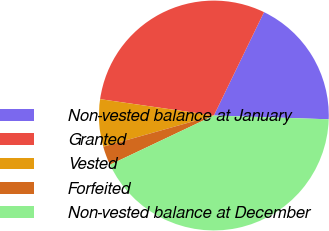Convert chart to OTSL. <chart><loc_0><loc_0><loc_500><loc_500><pie_chart><fcel>Non-vested balance at January<fcel>Granted<fcel>Vested<fcel>Forfeited<fcel>Non-vested balance at December<nl><fcel>18.33%<fcel>29.91%<fcel>6.65%<fcel>2.67%<fcel>42.43%<nl></chart> 